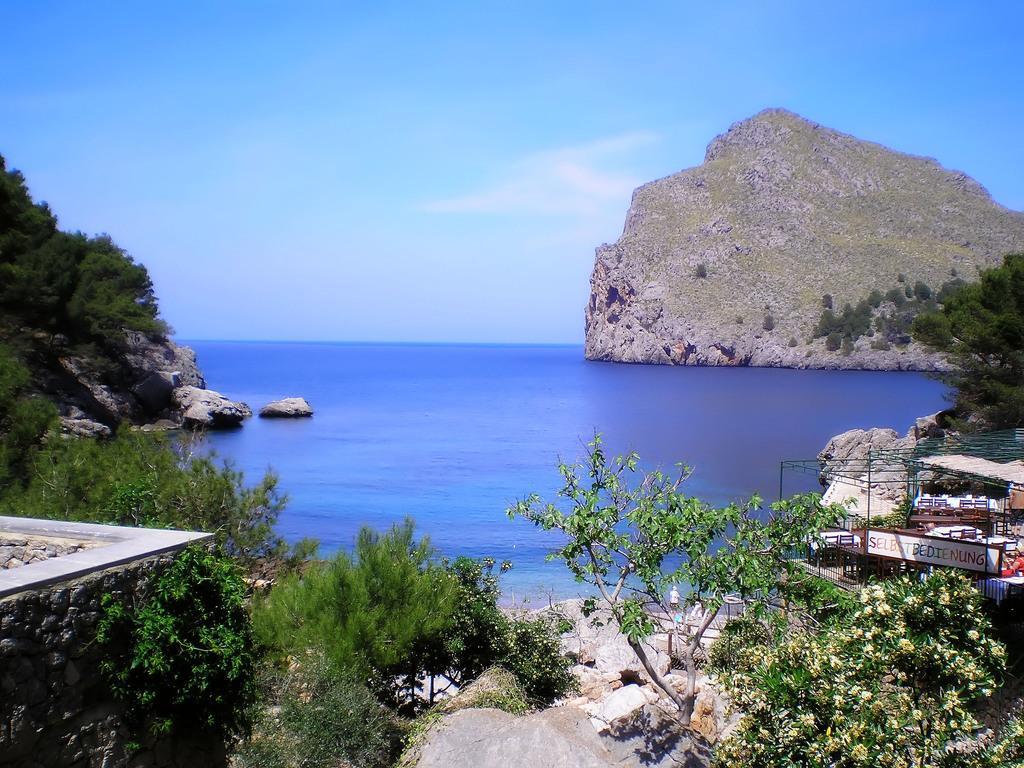How would you summarize this image in a sentence or two? In this picture there are few chairs,tables and some other objects in the right corner and there are few trees and rocks in the left corner and there is water and a mountain in the background. 